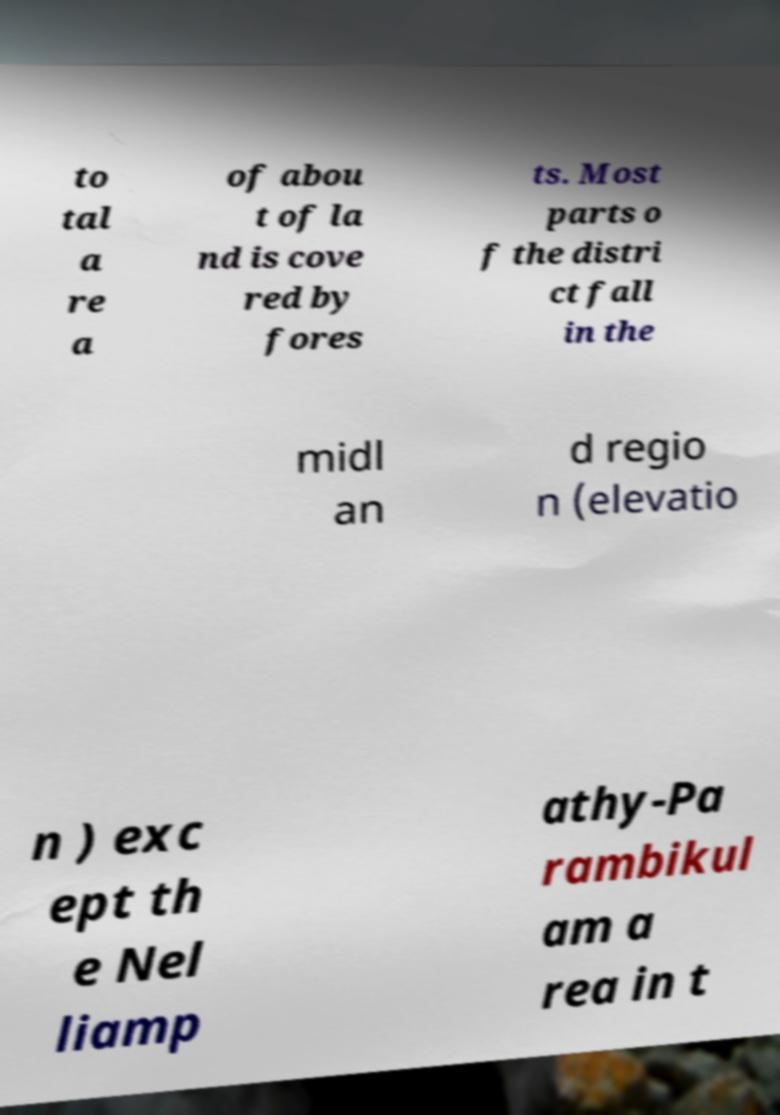Could you assist in decoding the text presented in this image and type it out clearly? to tal a re a of abou t of la nd is cove red by fores ts. Most parts o f the distri ct fall in the midl an d regio n (elevatio n ) exc ept th e Nel liamp athy-Pa rambikul am a rea in t 